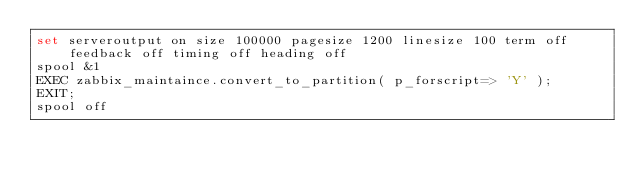<code> <loc_0><loc_0><loc_500><loc_500><_SQL_>set serveroutput on size 100000 pagesize 1200 linesize 100 term off feedback off timing off heading off
spool &1
EXEC zabbix_maintaince.convert_to_partition( p_forscript=> 'Y' );
EXIT;
spool off
</code> 